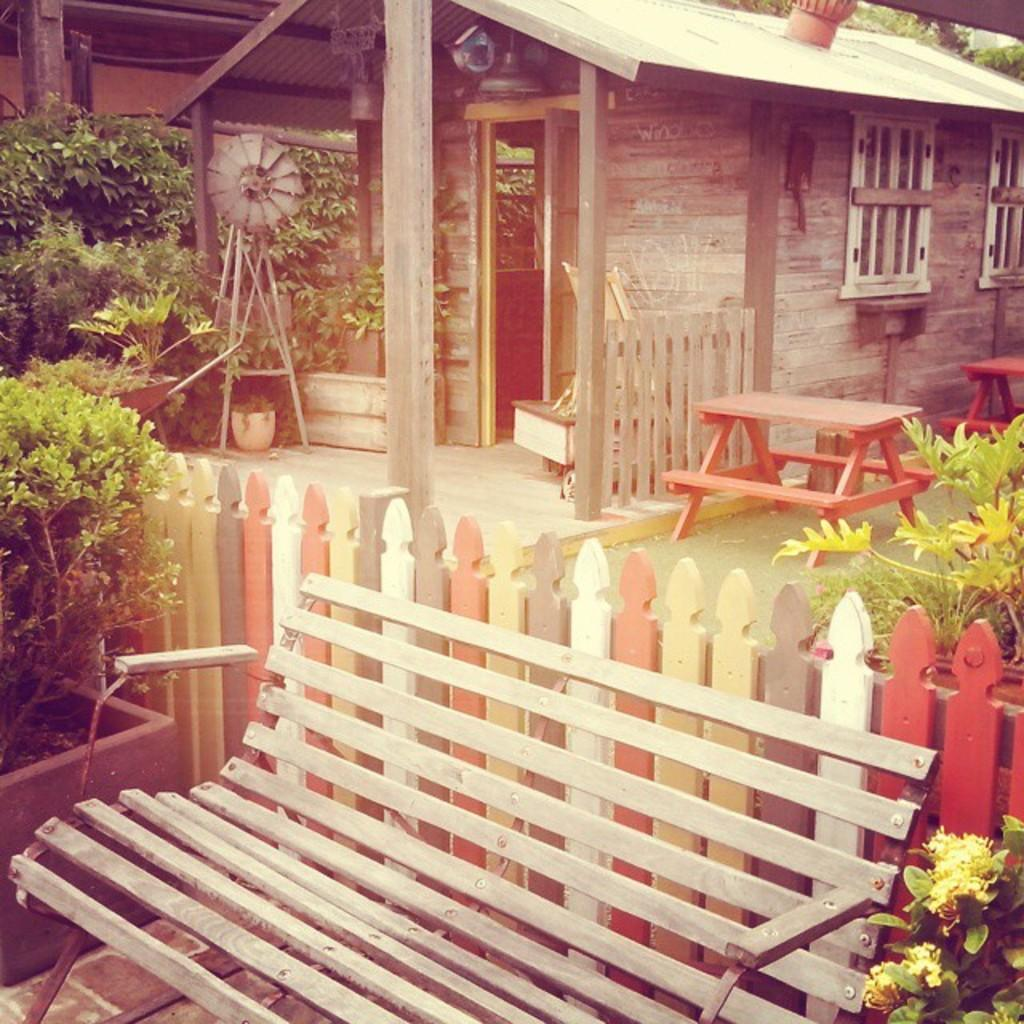What type of structure is visible in the image? There is a house in the image. What is located in front of the house? There is a bench in front of the house. What piece of furniture can be seen in the image? There is a table in the image. What type of vegetation is present in the image? There are plants in the image. What feature of the house is visible in the image? There is a window in the image. What type of oil can be seen dripping from the window in the image? There is no oil present in the image, and the window is not depicted as dripping anything. 